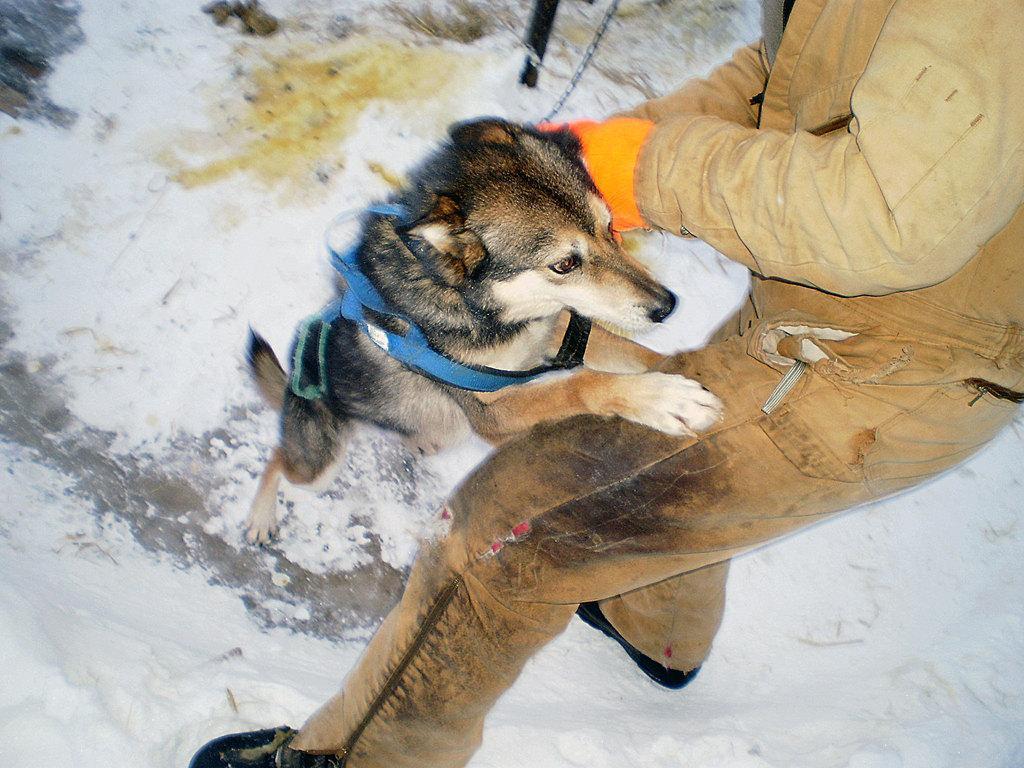Could you give a brief overview of what you see in this image? In this picture there is a dog and a person. The picture consists of snow. At the top there is a pole and a chain. 